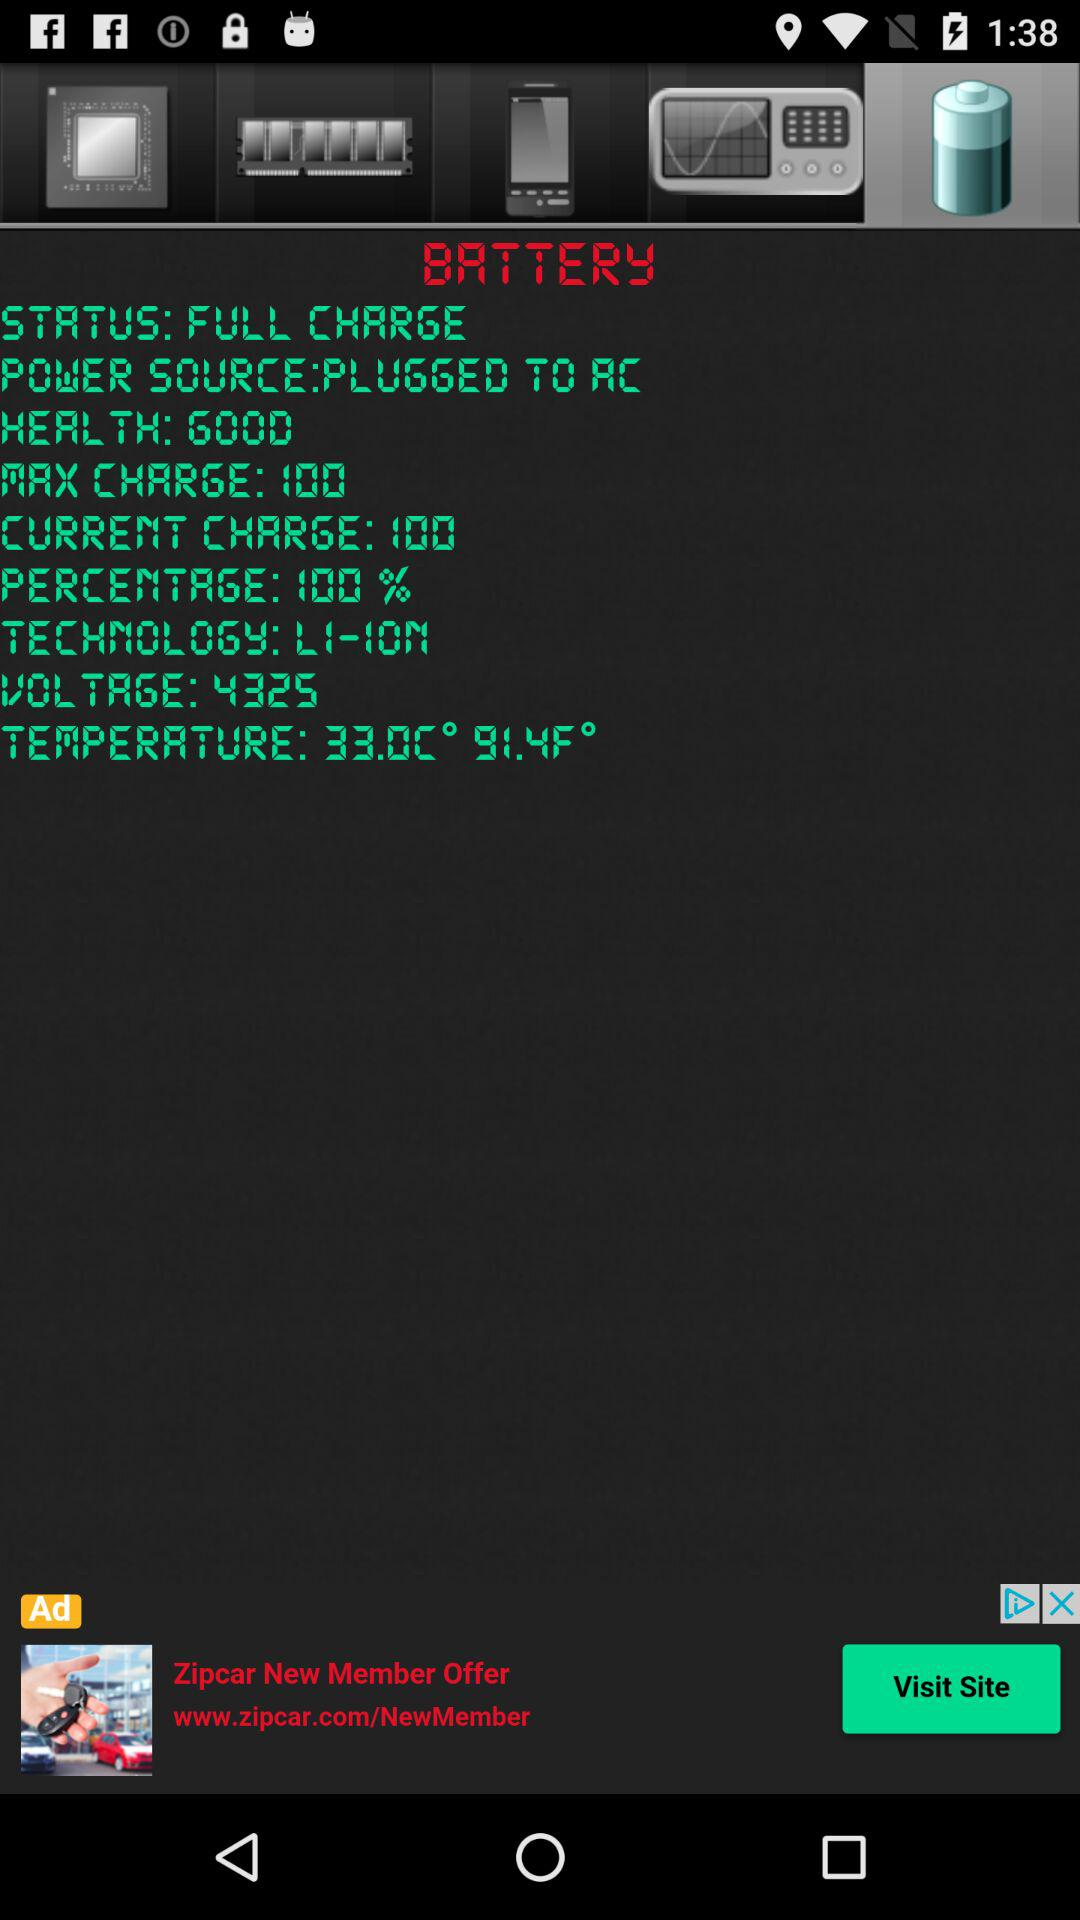What is the temperature? The temperatures are 33.0 °C and 91.4 °F. 